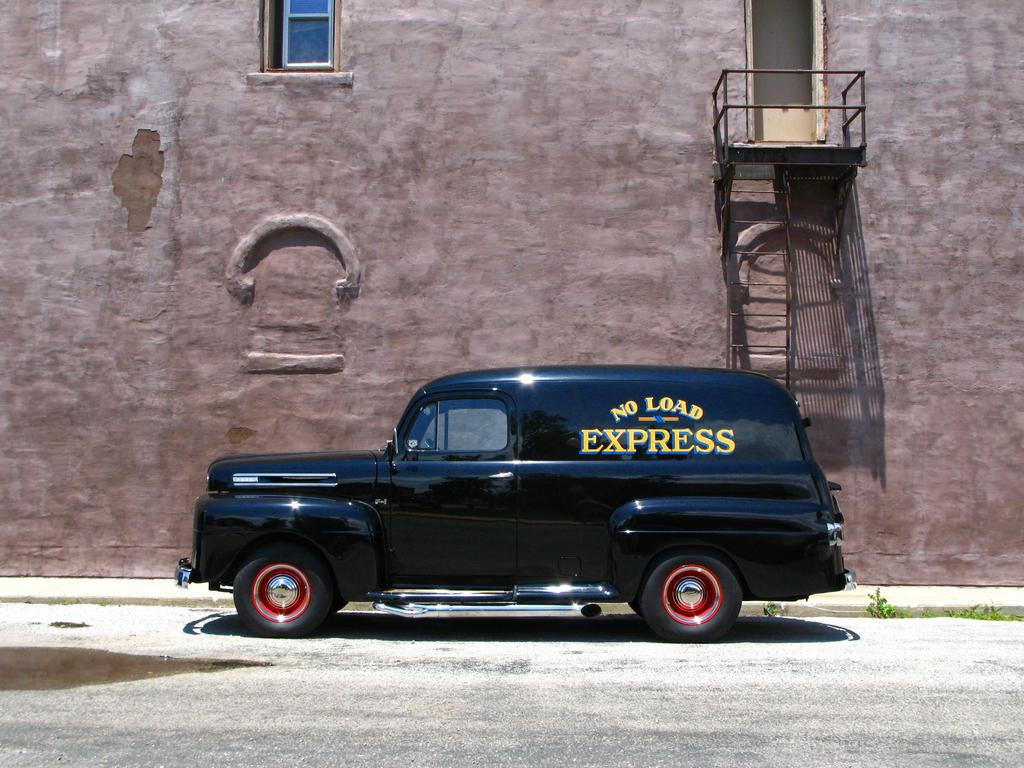What color is the car in the image? The car in the image is black. Where is the car located in the image? The car is parked on the road. What can be seen in the background of the image? There is a building wall in the background of the image. What features are present on the building wall? The building wall has a window, a door, and stairs. Are there any plants visible in the image? Yes, there are small plants visible in the image. How many people are on the team that is playing with the brush in the image? There is no team or brush present in the image. 